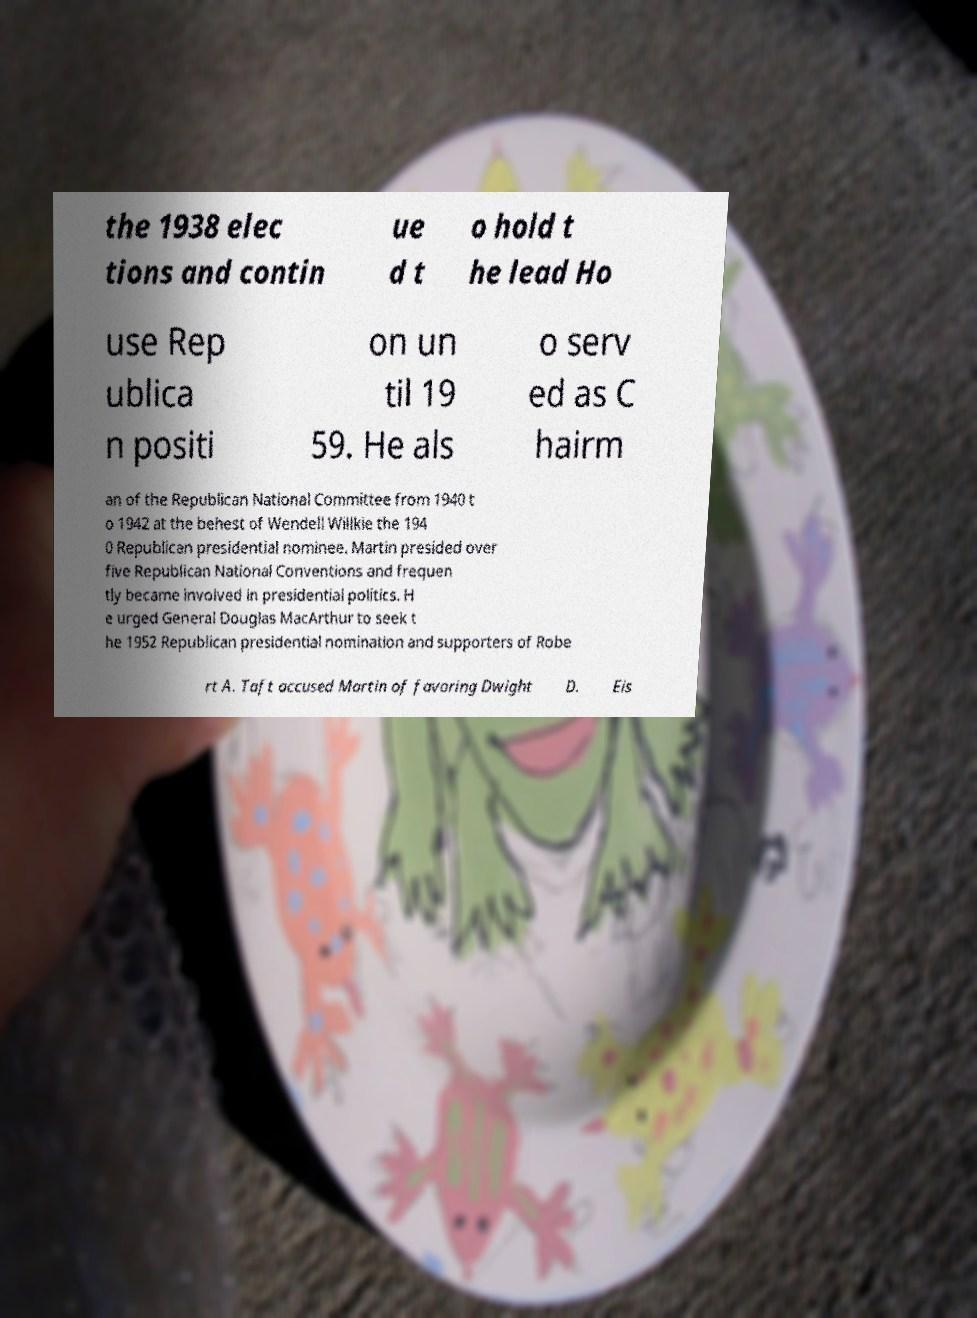Could you assist in decoding the text presented in this image and type it out clearly? the 1938 elec tions and contin ue d t o hold t he lead Ho use Rep ublica n positi on un til 19 59. He als o serv ed as C hairm an of the Republican National Committee from 1940 t o 1942 at the behest of Wendell Willkie the 194 0 Republican presidential nominee. Martin presided over five Republican National Conventions and frequen tly became involved in presidential politics. H e urged General Douglas MacArthur to seek t he 1952 Republican presidential nomination and supporters of Robe rt A. Taft accused Martin of favoring Dwight D. Eis 